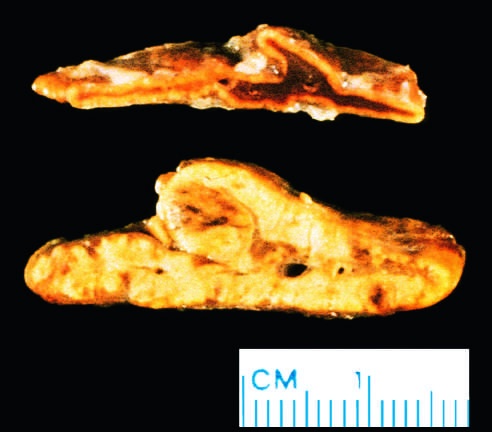what is yellow and thickened?
Answer the question using a single word or phrase. The adrenal cortex 